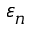<formula> <loc_0><loc_0><loc_500><loc_500>\varepsilon _ { n }</formula> 